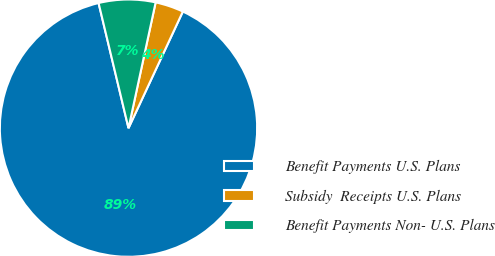<chart> <loc_0><loc_0><loc_500><loc_500><pie_chart><fcel>Benefit Payments U.S. Plans<fcel>Subsidy  Receipts U.S. Plans<fcel>Benefit Payments Non- U.S. Plans<nl><fcel>89.32%<fcel>3.56%<fcel>7.12%<nl></chart> 